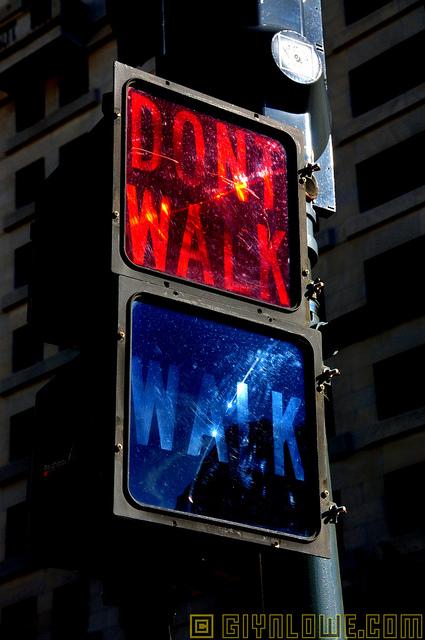Could this sign be in transition?
Concise answer only. Yes. Are both sign's lit up?
Concise answer only. No. What is written in the photo?
Short answer required. Don't walk. 